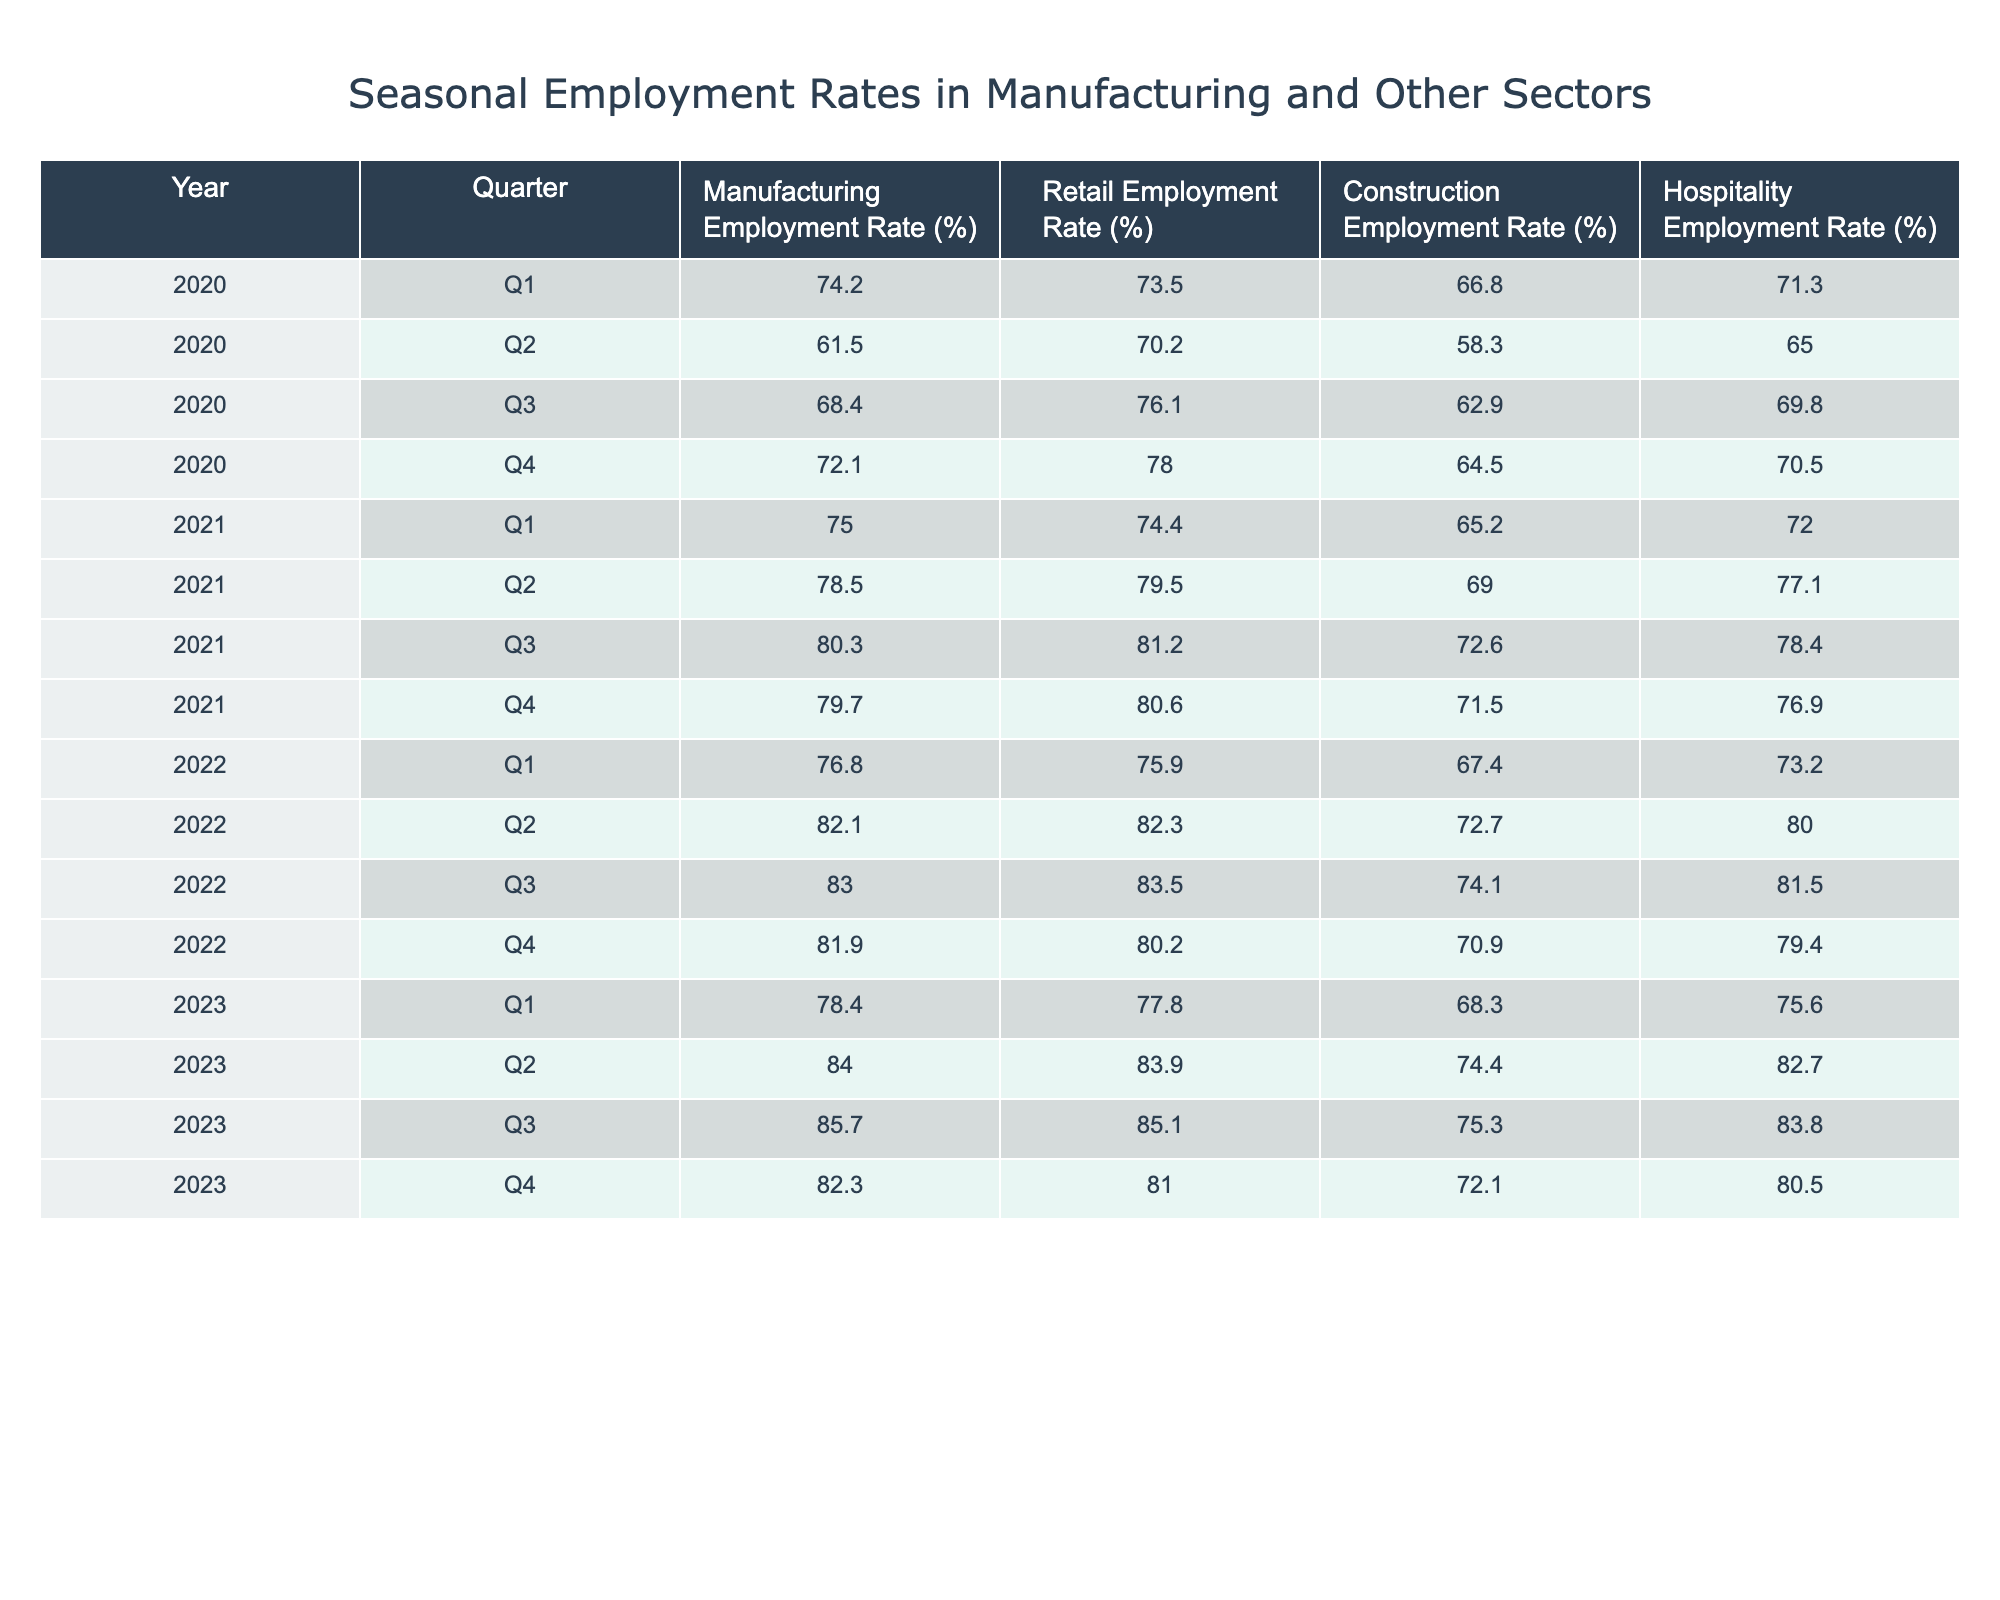What was the manufacturing employment rate in Q2 of 2022? The manufacturing employment rate for Q2 of 2022 can be found directly in the table. It is listed under the column for "Manufacturing Employment Rate (%)" in the row corresponding to 2022, Q2.
Answer: 82.1 Which sector had the highest employment rate in Q3 of 2023? In Q3 of 2023, we need to compare the values in the different columns: Manufacturing (85.7), Retail (85.1), Construction (75.3), and Hospitality (83.8). The highest value is for Manufacturing at 85.7.
Answer: Manufacturing What is the difference between the manufacturing employment rate in Q1 of 2020 and Q1 of 2021? The manufacturing employment rate in Q1 of 2020 is 74.2%, and in Q1 of 2021, it is 75.0%. The difference is calculated by subtracting the former from the latter: 75.0 - 74.2 = 0.8.
Answer: 0.8 Is the manufacturing employment rate in Q4 of 2021 higher than the retail employment rate in the same quarter? In Q4 of 2021, the manufacturing employment rate is 79.7%, while the retail employment rate is 80.6%. Since 79.7 is less than 80.6, the answer is no.
Answer: No What is the average manufacturing employment rate for the year 2022? To find the average for 2022, we need to sum the manufacturing rates for each quarter: Q1 (76.8), Q2 (82.1), Q3 (83.0), Q4 (81.9). The total is 76.8 + 82.1 + 83.0 + 81.9 = 323.8. Dividing by 4 (the number of quarters) gives us an average of 323.8 / 4 = 80.95.
Answer: 80.95 What was the trend in manufacturing employment rates from Q2 2020 to Q4 2023? To determine the trend, we examine the manufacturing employment rates for Q2 of 2020 (61.5%), Q4 of 2023 (82.3%). This represents an increase of 20.8% over this period, indicating a positive trend in manufacturing employment rates.
Answer: Increasing In which quarter of 2022 did retail employment show the highest rate? By checking the table for retail employment rates in 2022, we find that Q2 (82.3%) and Q3 (83.5%) represent the increasing values, with Q3 being the highest.
Answer: Q3 2022 Was there a quarter in 2021 where manufacturing employment rates fell compared to the previous quarter? Analyzing the manufacturing rates for 2021, we find that Q1 (75.0) to Q2 (78.5), Q2 to Q3 (80.3), and Q3 to Q4 (79.7) show increases or stability. The only decrease is from Q3 to Q4.
Answer: Yes What is the total manufacturing employment rate percentage across all quarters in 2023? To find this total, we sum the manufacturing employment rates for 2023: Q1 (78.4), Q2 (84.0), Q3 (85.7), Q4 (82.3). The total equals 78.4 + 84.0 + 85.7 + 82.3 = 330.4.
Answer: 330.4 